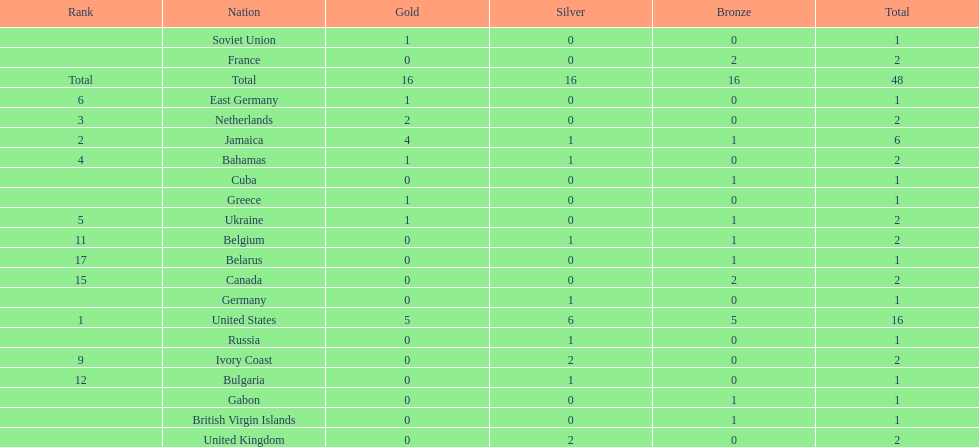After the united states, what country won the most gold medals. Jamaica. 